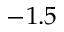Convert formula to latex. <formula><loc_0><loc_0><loc_500><loc_500>- 1 . 5</formula> 